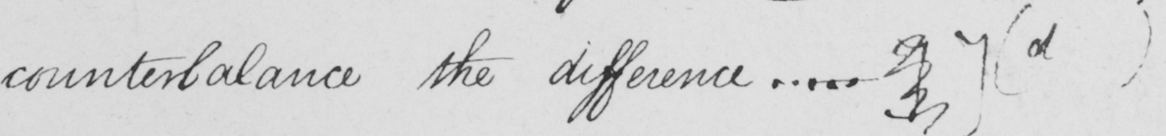Please transcribe the handwritten text in this image. counterbalance the difference .... . ]   ]   ( d ) 